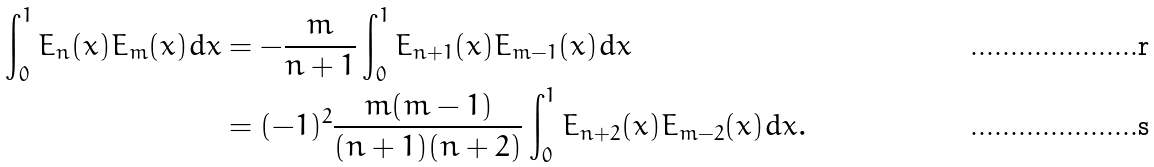Convert formula to latex. <formula><loc_0><loc_0><loc_500><loc_500>\int _ { 0 } ^ { 1 } E _ { n } ( x ) E _ { m } ( x ) d x & = - \frac { m } { n + 1 } \int _ { 0 } ^ { 1 } E _ { n + 1 } ( x ) E _ { m - 1 } ( x ) d x \\ & = ( - 1 ) ^ { 2 } \frac { m ( m - 1 ) } { ( n + 1 ) ( n + 2 ) } \int _ { 0 } ^ { 1 } E _ { n + 2 } ( x ) E _ { m - 2 } ( x ) d x .</formula> 